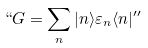<formula> <loc_0><loc_0><loc_500><loc_500>` ` G = \sum _ { n } | n \rangle \varepsilon _ { n } \langle n | ^ { \prime \prime }</formula> 